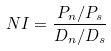<formula> <loc_0><loc_0><loc_500><loc_500>N I = \frac { P _ { n } / P _ { s } } { D _ { n } / D _ { s } }</formula> 